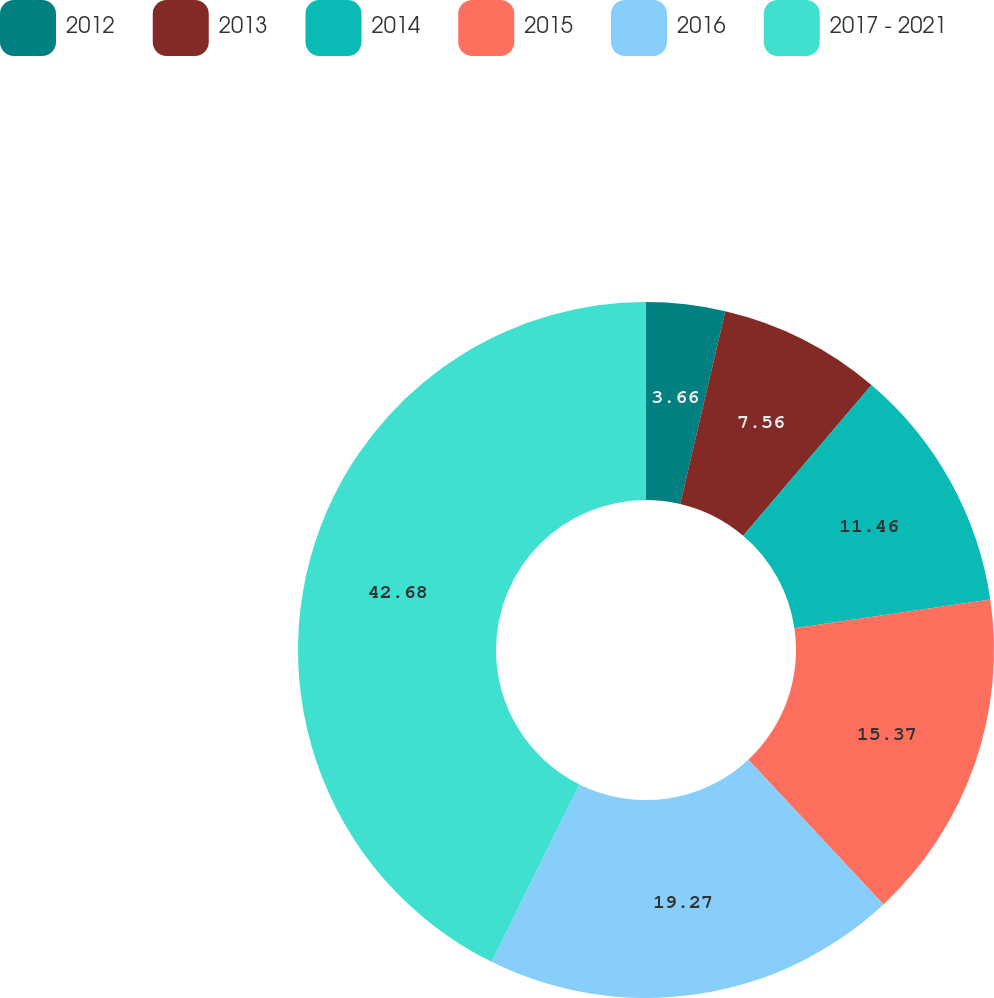Convert chart. <chart><loc_0><loc_0><loc_500><loc_500><pie_chart><fcel>2012<fcel>2013<fcel>2014<fcel>2015<fcel>2016<fcel>2017 - 2021<nl><fcel>3.66%<fcel>7.56%<fcel>11.46%<fcel>15.37%<fcel>19.27%<fcel>42.68%<nl></chart> 